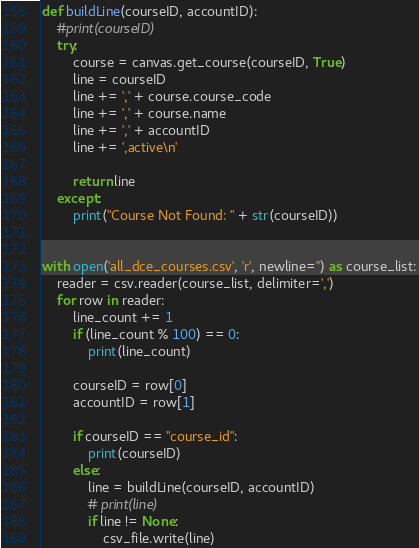Convert code to text. <code><loc_0><loc_0><loc_500><loc_500><_Python_>def buildLine(courseID, accountID):
    #print(courseID)
    try:
        course = canvas.get_course(courseID, True)
        line = courseID
        line += ',' + course.course_code
        line += ',' + course.name
        line += ',' + accountID
        line += ',active\n'

        return line
    except:
        print("Course Not Found: " + str(courseID))


with open('all_dce_courses.csv', 'r', newline='') as course_list:
    reader = csv.reader(course_list, delimiter=',')
    for row in reader:
        line_count += 1
        if (line_count % 100) == 0:
            print(line_count)

        courseID = row[0]
        accountID = row[1]

        if courseID == "course_id":
            print(courseID)
        else:
            line = buildLine(courseID, accountID)
            # print(line)
            if line != None:
                csv_file.write(line)</code> 